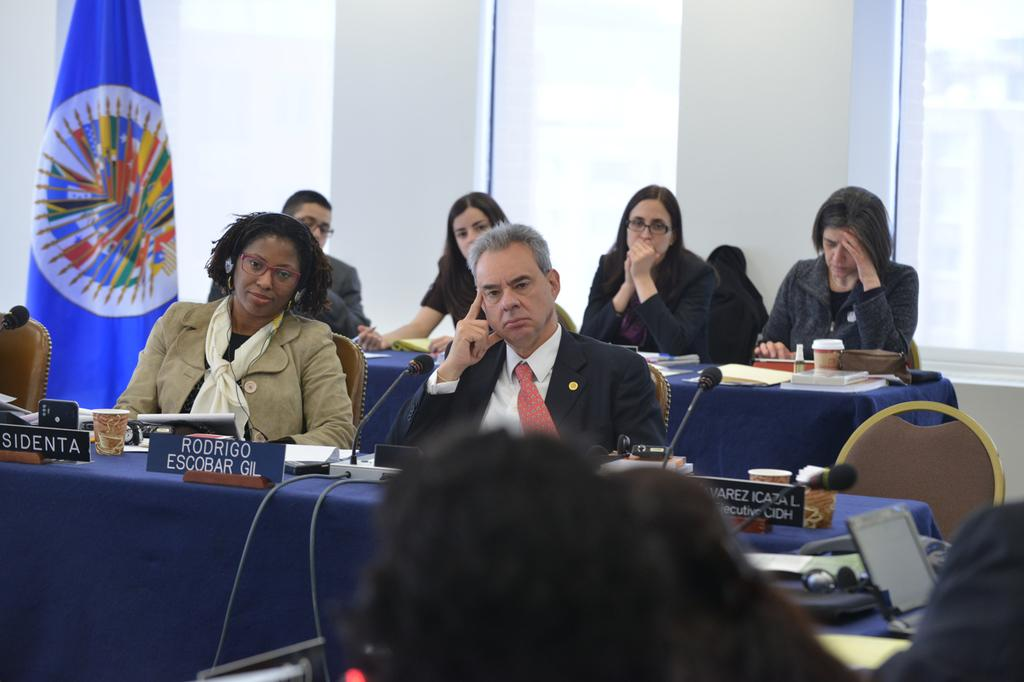What are the people in the image doing? The people are seated in the image. What are the people wearing? The people are wearing suits. What color are the tables in the image? The tables are blue. What objects are on the tables? Microphones, wires, name plates, and glasses are on the tables. Where is the blue flag located in the image? The blue flag is on the left side of the image. How many clocks are visible on the tables in the image? There are no clocks visible on the tables in the image. What type of ship can be seen sailing in the background of the image? There is no ship present in the image; it only features people seated at tables with various objects. 